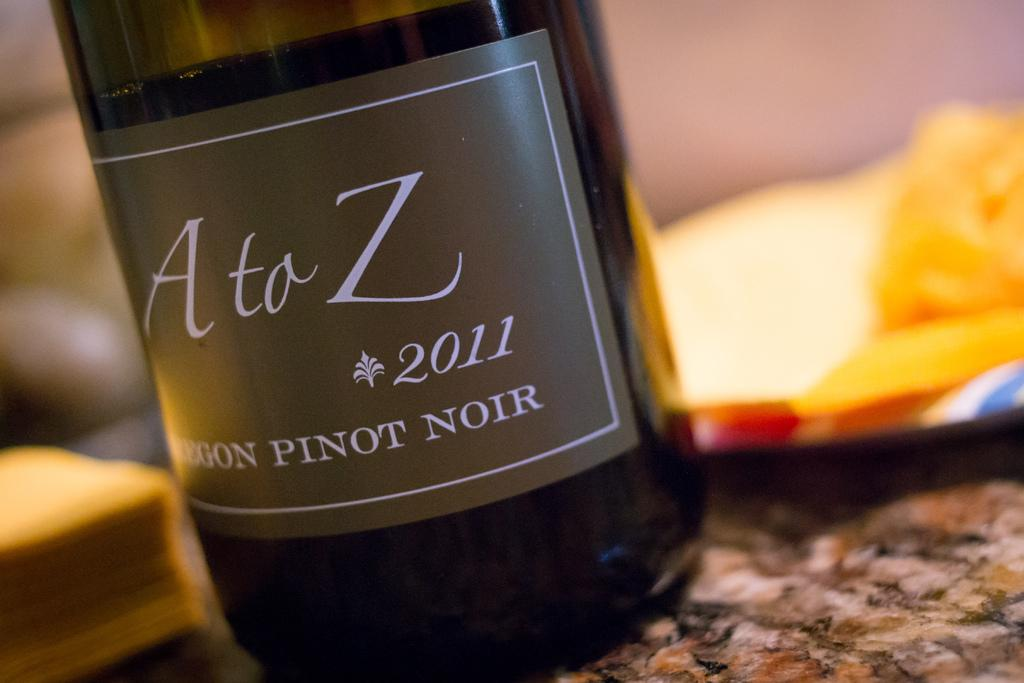<image>
Summarize the visual content of the image. The A to Z wine is a Pinot Noir made in 2011. 